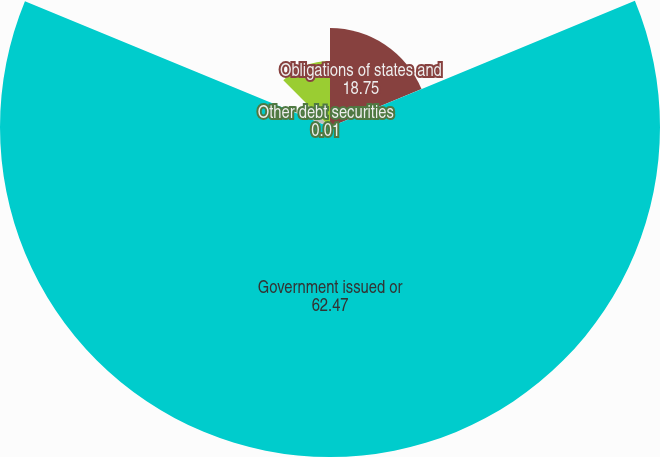Convert chart to OTSL. <chart><loc_0><loc_0><loc_500><loc_500><pie_chart><fcel>Obligations of states and<fcel>Government issued or<fcel>Privately issued<fcel>Other debt securities<fcel>Equity securities<nl><fcel>18.75%<fcel>62.47%<fcel>6.26%<fcel>0.01%<fcel>12.5%<nl></chart> 